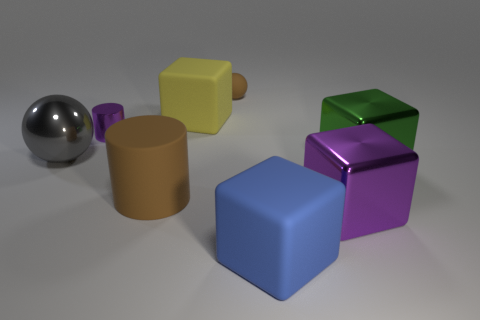Is there a purple object that has the same material as the yellow object?
Offer a very short reply. No. There is a brown object that is the same size as the yellow matte object; what material is it?
Ensure brevity in your answer.  Rubber. How many large yellow things have the same shape as the gray metal thing?
Your response must be concise. 0. There is a gray sphere that is made of the same material as the large purple block; what is its size?
Give a very brief answer. Large. What material is the object that is on the left side of the yellow matte block and right of the tiny shiny object?
Keep it short and to the point. Rubber. What number of other rubber cylinders are the same size as the brown cylinder?
Ensure brevity in your answer.  0. What is the material of the big yellow object that is the same shape as the blue matte object?
Provide a short and direct response. Rubber. How many things are spheres that are right of the large cylinder or large matte cubes right of the tiny sphere?
Your answer should be very brief. 2. Do the yellow rubber object and the purple object that is in front of the large gray object have the same shape?
Offer a terse response. Yes. What shape is the matte object that is in front of the shiny cube that is in front of the cylinder in front of the gray metal object?
Your response must be concise. Cube. 